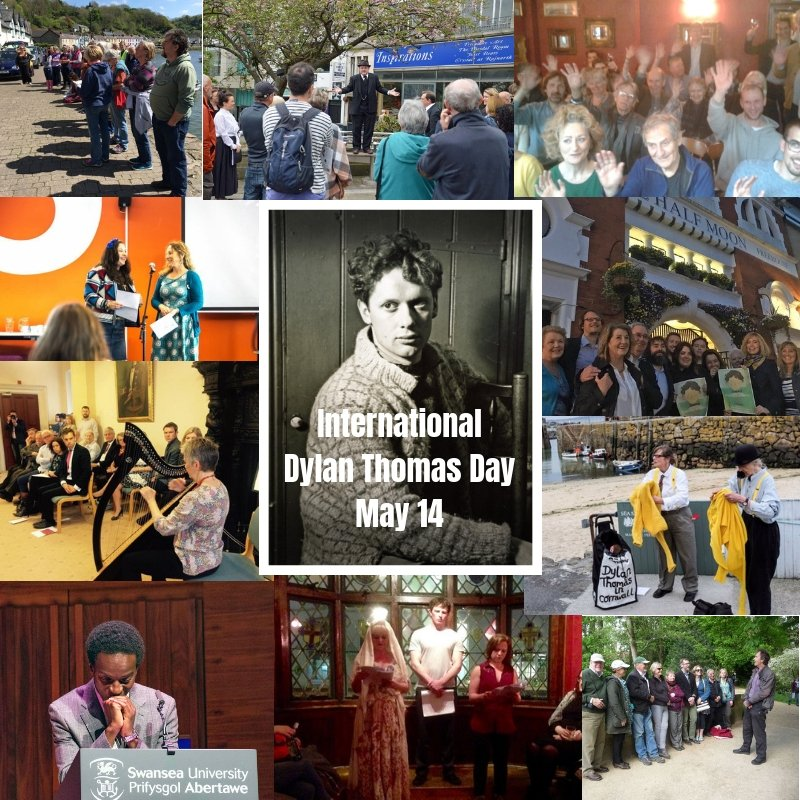Create a whimsical and imaginative scenario involving the people gathered in the photo on the bottom right corner. In an extraordinary twist of events, the group of people gathered in the bottom right photo suddenly finds themselves transported into a whimsical world inspired by Dylan Thomas's poetry. The trees around them morph into fantastical shapes, and the air fills with the sound of poetic whispers. As they walk through this enchanted wood, they encounter characters from Thomas's works, who guide them on a quest to uncover a hidden manuscript believed to contain an unpublished poem of great importance. Along the way, they solve riddles and experience magical moments that bring Thomas's evocative language to life in vivid, surreal scenes. 